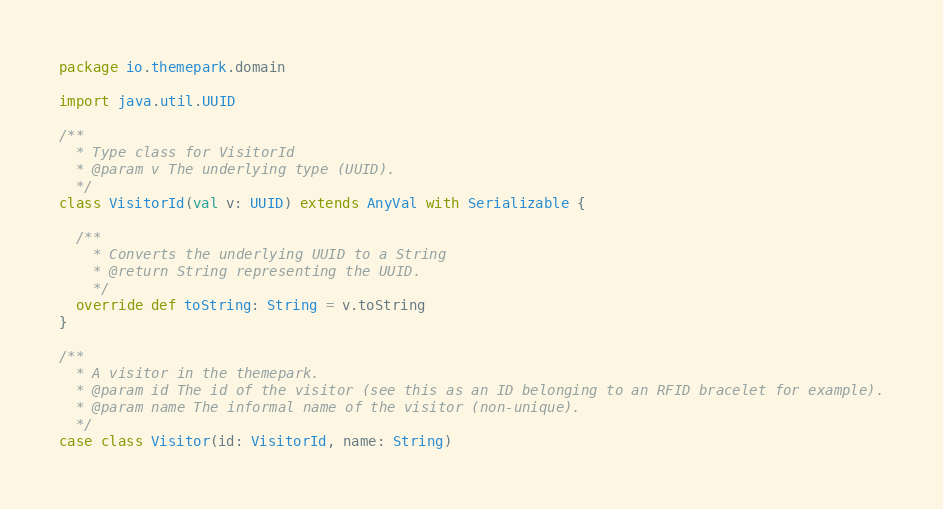Convert code to text. <code><loc_0><loc_0><loc_500><loc_500><_Scala_>package io.themepark.domain

import java.util.UUID

/**
  * Type class for VisitorId
  * @param v The underlying type (UUID).
  */
class VisitorId(val v: UUID) extends AnyVal with Serializable {

  /**
    * Converts the underlying UUID to a String
    * @return String representing the UUID.
    */
  override def toString: String = v.toString
}

/**
  * A visitor in the themepark.
  * @param id The id of the visitor (see this as an ID belonging to an RFID bracelet for example).
  * @param name The informal name of the visitor (non-unique).
  */
case class Visitor(id: VisitorId, name: String)
</code> 